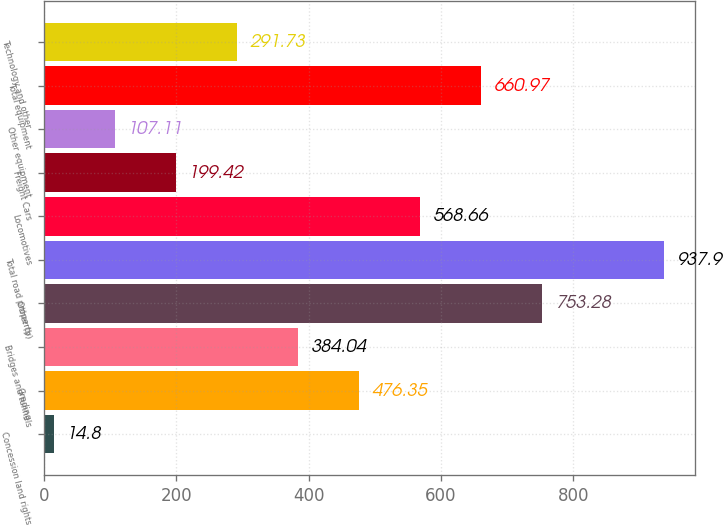Convert chart to OTSL. <chart><loc_0><loc_0><loc_500><loc_500><bar_chart><fcel>Concession land rights<fcel>Grading<fcel>Bridges and tunnels<fcel>Other (b)<fcel>Total road property<fcel>Locomotives<fcel>Freight Cars<fcel>Other equipment<fcel>Total equipment<fcel>Technology and other<nl><fcel>14.8<fcel>476.35<fcel>384.04<fcel>753.28<fcel>937.9<fcel>568.66<fcel>199.42<fcel>107.11<fcel>660.97<fcel>291.73<nl></chart> 